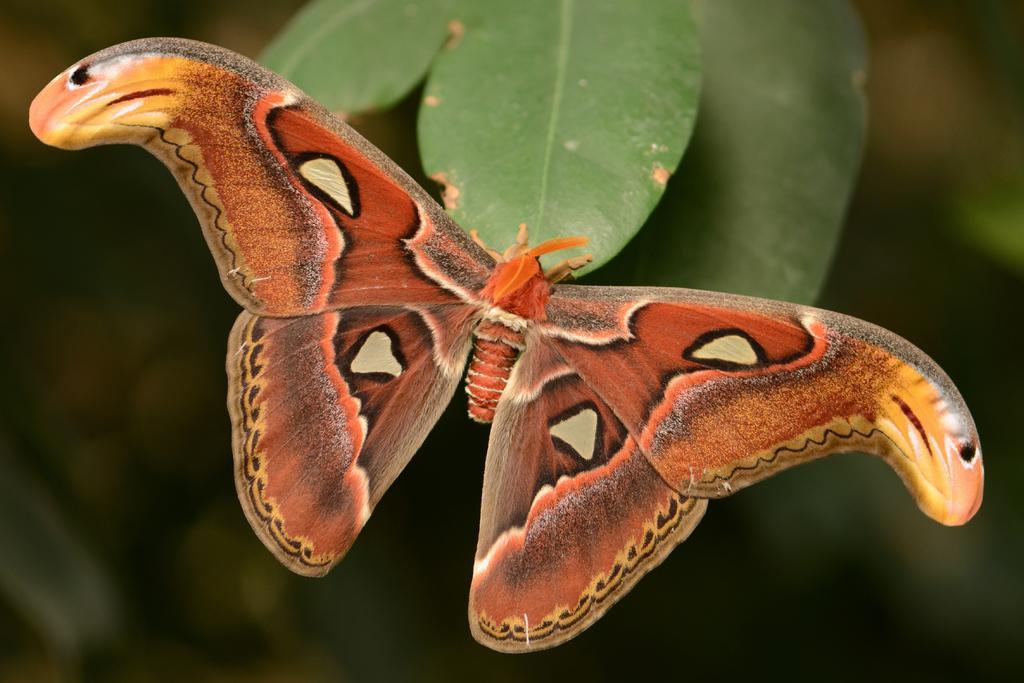Please provide a concise description of this image. In this picture I can observe a butterfly. The butterfly is in orange color. There are some leaves. The background is completely blurred. 